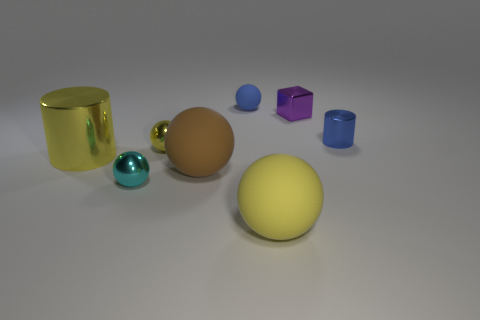Subtract all brown spheres. How many spheres are left? 4 Subtract all large brown rubber spheres. How many spheres are left? 4 Subtract all cyan spheres. Subtract all purple blocks. How many spheres are left? 4 Add 1 yellow rubber cylinders. How many objects exist? 9 Subtract 0 purple spheres. How many objects are left? 8 Subtract all cubes. How many objects are left? 7 Subtract all large brown balls. Subtract all small rubber objects. How many objects are left? 6 Add 1 big yellow rubber objects. How many big yellow rubber objects are left? 2 Add 4 small blue rubber objects. How many small blue rubber objects exist? 5 